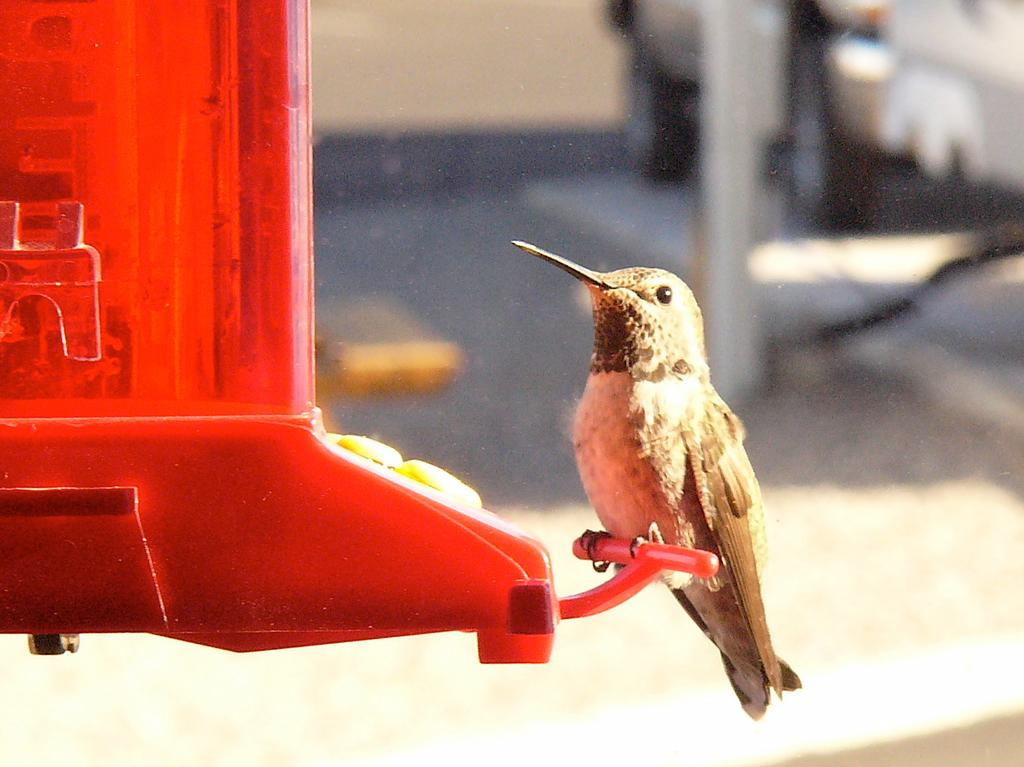What type of animal is in the image? There is a bird in the image. Where was the image taken? The image was taken outside. What physical features does the bird have? The bird has feathers, eyes, a beak, and legs. What type of kitty can be seen playing with the bird in the image? There is no kitty present in the image, and the bird is not shown playing with any other animals. 